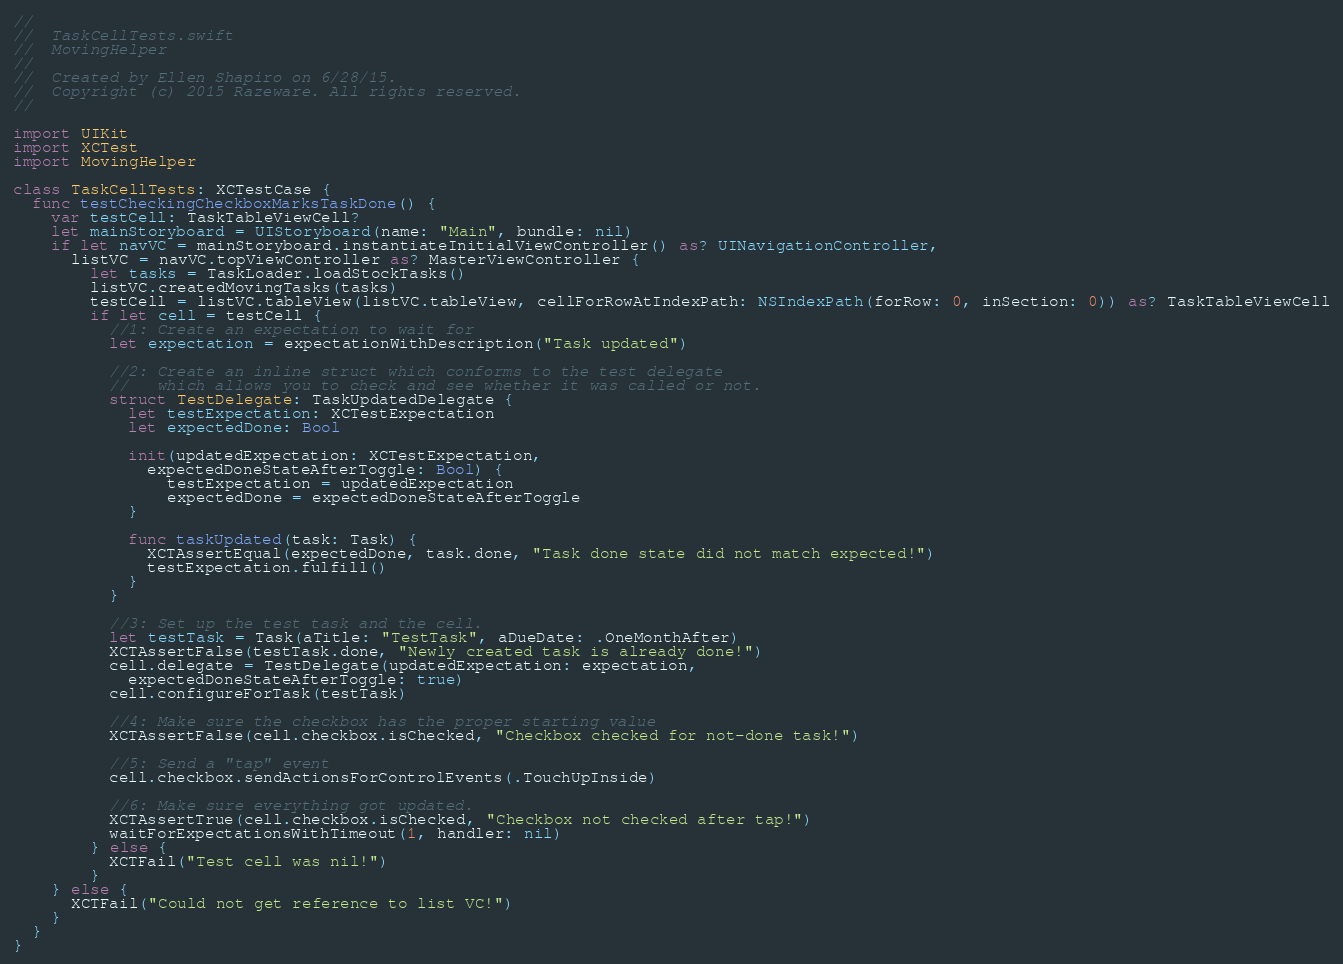<code> <loc_0><loc_0><loc_500><loc_500><_Swift_>//
//  TaskCellTests.swift
//  MovingHelper
//
//  Created by Ellen Shapiro on 6/28/15.
//  Copyright (c) 2015 Razeware. All rights reserved.
//

import UIKit
import XCTest
import MovingHelper

class TaskCellTests: XCTestCase {
  func testCheckingCheckboxMarksTaskDone() {
    var testCell: TaskTableViewCell?
    let mainStoryboard = UIStoryboard(name: "Main", bundle: nil)
    if let navVC = mainStoryboard.instantiateInitialViewController() as? UINavigationController,
      listVC = navVC.topViewController as? MasterViewController {
        let tasks = TaskLoader.loadStockTasks()
        listVC.createdMovingTasks(tasks)
        testCell = listVC.tableView(listVC.tableView, cellForRowAtIndexPath: NSIndexPath(forRow: 0, inSection: 0)) as? TaskTableViewCell
        if let cell = testCell {
          //1: Create an expectation to wait for
          let expectation = expectationWithDescription("Task updated")
          
          //2: Create an inline struct which conforms to the test delegate 
          //   which allows you to check and see whether it was called or not.
          struct TestDelegate: TaskUpdatedDelegate {
            let testExpectation: XCTestExpectation
            let expectedDone: Bool
            
            init(updatedExpectation: XCTestExpectation,
              expectedDoneStateAfterToggle: Bool) {
                testExpectation = updatedExpectation
                expectedDone = expectedDoneStateAfterToggle
            }
            
            func taskUpdated(task: Task) {
              XCTAssertEqual(expectedDone, task.done, "Task done state did not match expected!")
              testExpectation.fulfill()
            }
          }
          
          //3: Set up the test task and the cell.
          let testTask = Task(aTitle: "TestTask", aDueDate: .OneMonthAfter)
          XCTAssertFalse(testTask.done, "Newly created task is already done!")
          cell.delegate = TestDelegate(updatedExpectation: expectation,
            expectedDoneStateAfterToggle: true)
          cell.configureForTask(testTask)
          
          //4: Make sure the checkbox has the proper starting value
          XCTAssertFalse(cell.checkbox.isChecked, "Checkbox checked for not-done task!")
          
          //5: Send a "tap" event
          cell.checkbox.sendActionsForControlEvents(.TouchUpInside)
          
          //6: Make sure everything got updated.
          XCTAssertTrue(cell.checkbox.isChecked, "Checkbox not checked after tap!")
          waitForExpectationsWithTimeout(1, handler: nil)
        } else {
          XCTFail("Test cell was nil!")
        }
    } else {
      XCTFail("Could not get reference to list VC!")
    }
  }
}</code> 